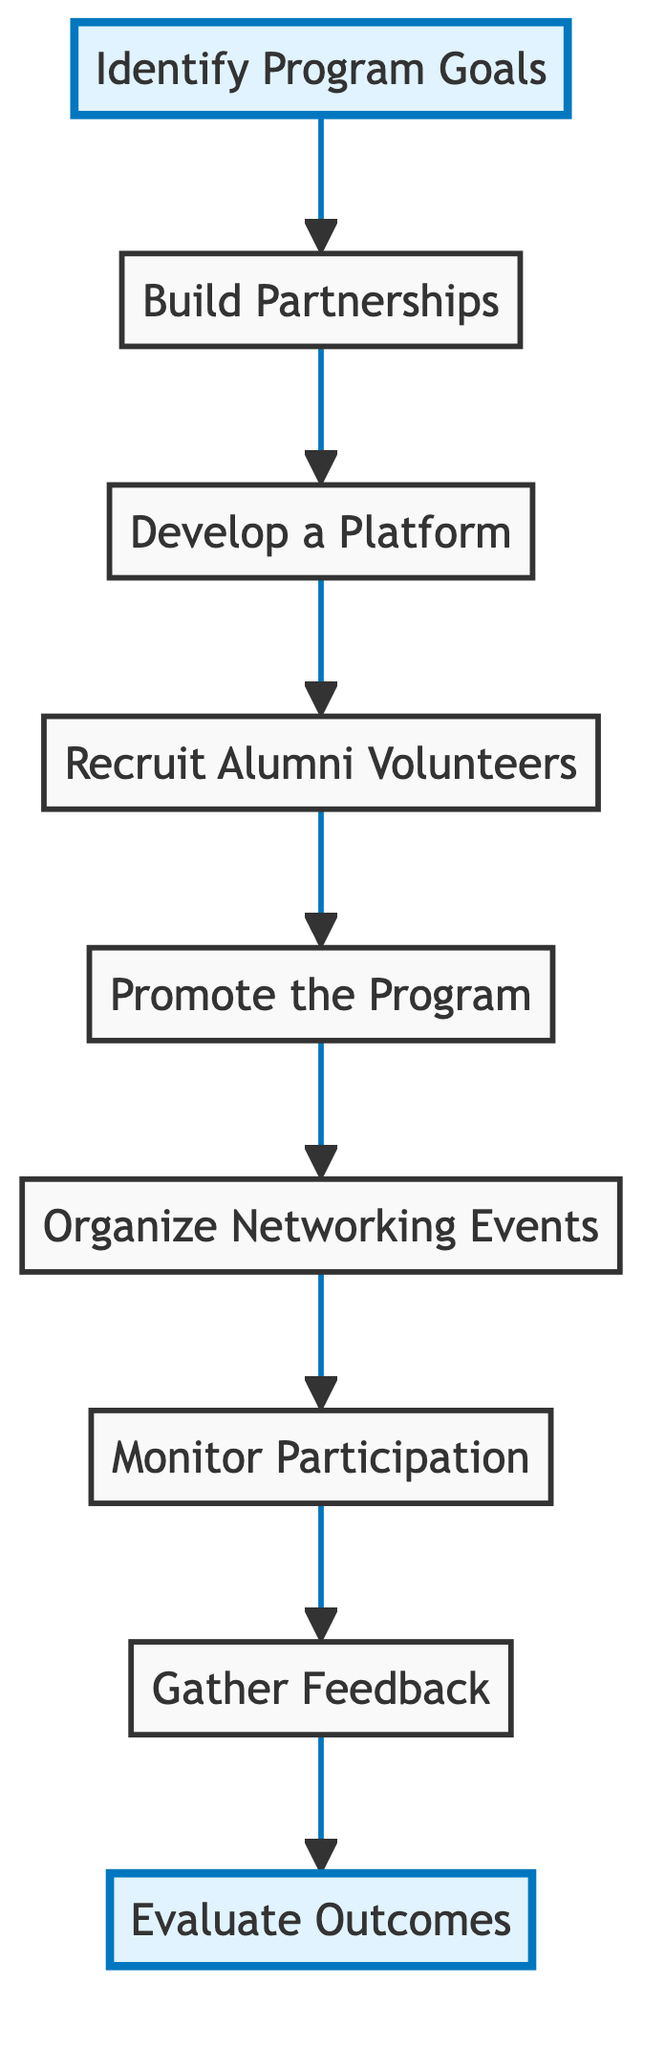What is the first step in the program? The first step in the program is to "Identify Program Goals," which is the initial node at the bottom of the flowchart.
Answer: Identify Program Goals How many total steps are outlined in the program? There are a total of eight steps outlined in the program, counted from "Identify Program Goals" to "Evaluate Outcomes."
Answer: 8 What follows "Recruit Alumni Volunteers" in the flow? "Promote the Program" follows "Recruit Alumni Volunteers," indicating the sequential nature of the steps.
Answer: Promote the Program Which step involves tracking engagement metrics? The step that involves tracking engagement metrics is "Monitor Participation," which comes after organizing networking events.
Answer: Monitor Participation Which two steps are highlighted in the diagram? The two highlighted steps are "Identify Program Goals" and "Evaluate Outcomes." These are emphasized to denote their importance in the program's process.
Answer: Identify Program Goals, Evaluate Outcomes What is the relationship between "Gather Feedback" and "Evaluate Outcomes"? "Gather Feedback" is a preceding step to "Evaluate Outcomes," suggesting that feedback is collected before assessing the program's success.
Answer: Gather Feedback Which step involves collaboration with university departments? The step that involves collaboration with university departments is "Build Partnerships," which is directly after "Identify Program Goals" in the flow.
Answer: Build Partnerships How does "Organize Networking Events" relate to the program's promotion? "Organize Networking Events" takes place after "Promote the Program," indicating that promoting the program is a prerequisite for organizing the events.
Answer: Organize Networking Events What is the last step in the flowchart? The last step in the flowchart is "Evaluate Outcomes," which is at the very top of the flowchart, signifying the conclusion of the networking program implementation process.
Answer: Evaluate Outcomes 